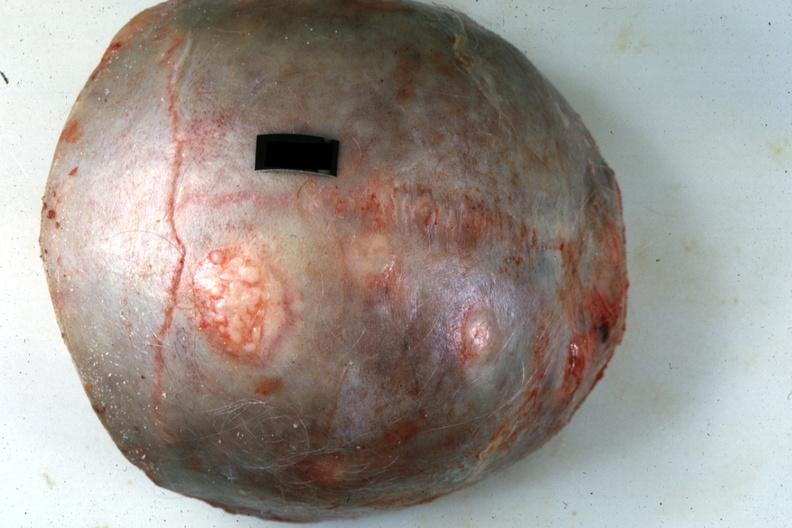s eye present?
Answer the question using a single word or phrase. No 